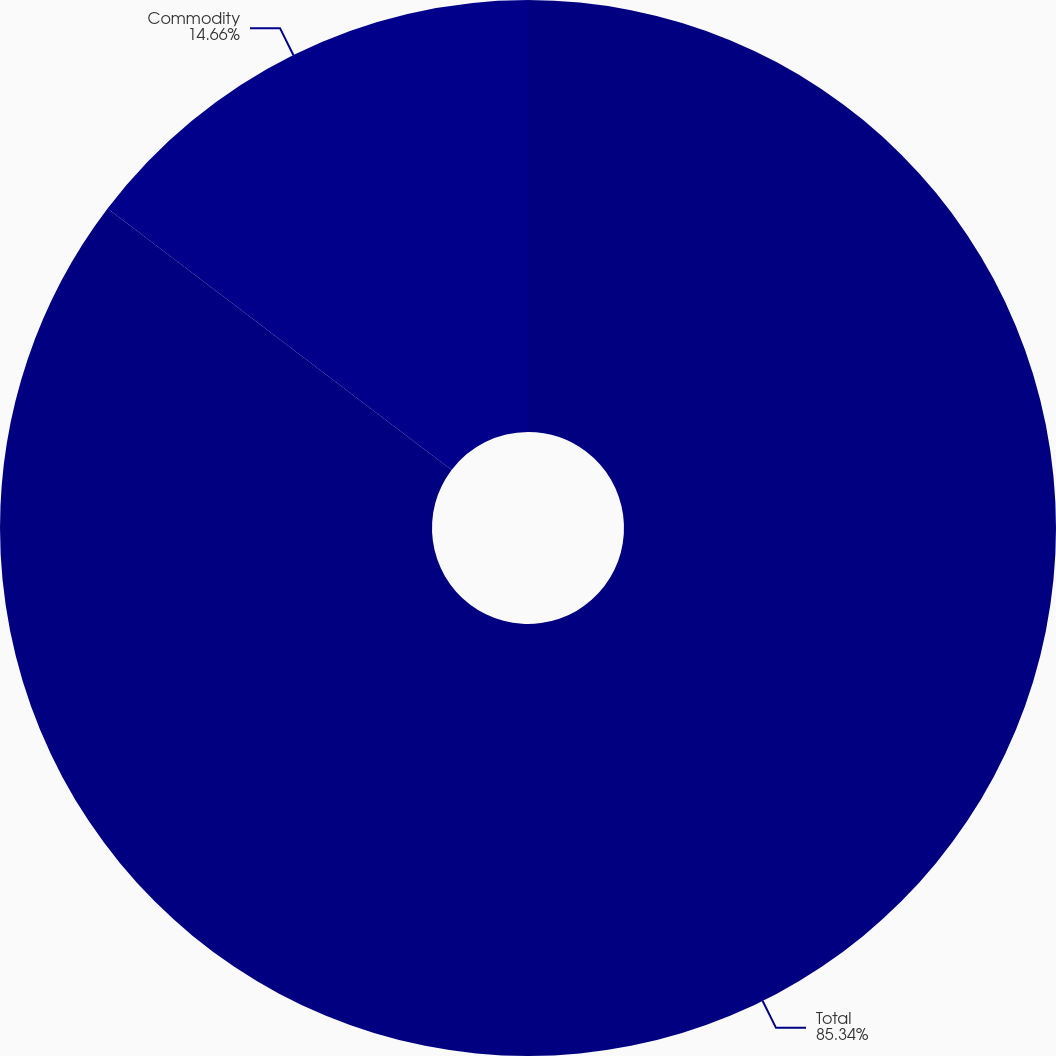Convert chart. <chart><loc_0><loc_0><loc_500><loc_500><pie_chart><fcel>Total<fcel>Commodity<nl><fcel>85.34%<fcel>14.66%<nl></chart> 